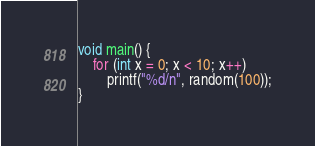Convert code to text. <code><loc_0><loc_0><loc_500><loc_500><_C_>
void main() {
    for (int x = 0; x < 10; x++)
        printf("%d/n", random(100));
}</code> 